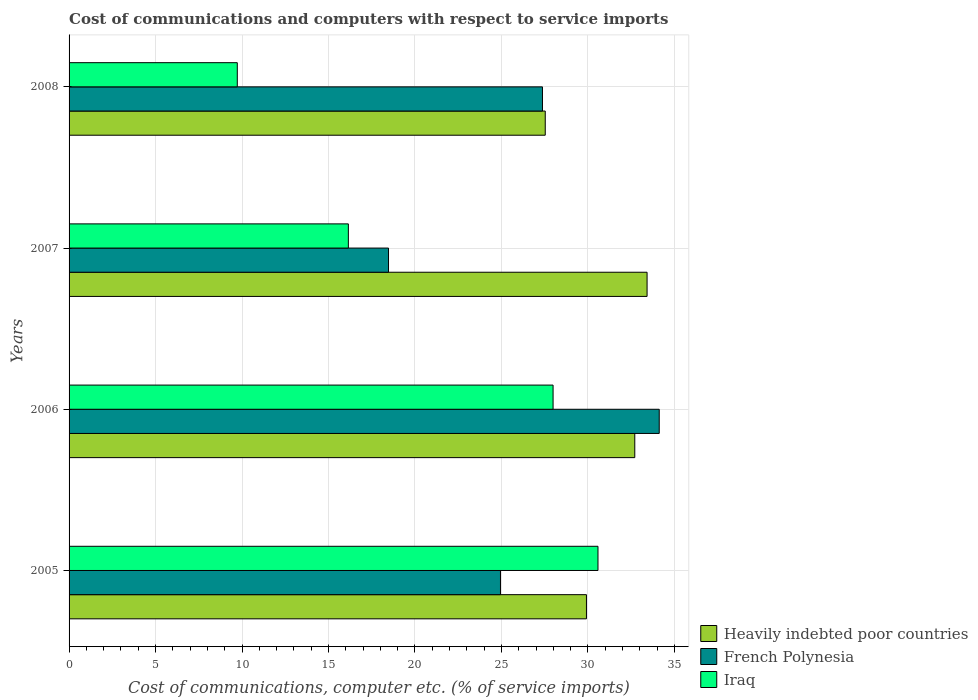How many bars are there on the 3rd tick from the top?
Your answer should be compact. 3. How many bars are there on the 4th tick from the bottom?
Offer a terse response. 3. What is the label of the 4th group of bars from the top?
Your response must be concise. 2005. In how many cases, is the number of bars for a given year not equal to the number of legend labels?
Provide a succinct answer. 0. What is the cost of communications and computers in Iraq in 2006?
Give a very brief answer. 27.99. Across all years, what is the maximum cost of communications and computers in Iraq?
Keep it short and to the point. 30.58. Across all years, what is the minimum cost of communications and computers in Iraq?
Your response must be concise. 9.73. In which year was the cost of communications and computers in Heavily indebted poor countries minimum?
Keep it short and to the point. 2008. What is the total cost of communications and computers in Heavily indebted poor countries in the graph?
Give a very brief answer. 123.58. What is the difference between the cost of communications and computers in Iraq in 2006 and that in 2008?
Keep it short and to the point. 18.26. What is the difference between the cost of communications and computers in Iraq in 2006 and the cost of communications and computers in French Polynesia in 2008?
Your answer should be very brief. 0.61. What is the average cost of communications and computers in Iraq per year?
Keep it short and to the point. 21.11. In the year 2005, what is the difference between the cost of communications and computers in Iraq and cost of communications and computers in French Polynesia?
Provide a short and direct response. 5.64. In how many years, is the cost of communications and computers in Heavily indebted poor countries greater than 17 %?
Your response must be concise. 4. What is the ratio of the cost of communications and computers in French Polynesia in 2005 to that in 2007?
Offer a very short reply. 1.35. Is the cost of communications and computers in Heavily indebted poor countries in 2005 less than that in 2007?
Keep it short and to the point. Yes. What is the difference between the highest and the second highest cost of communications and computers in Heavily indebted poor countries?
Your answer should be very brief. 0.71. What is the difference between the highest and the lowest cost of communications and computers in Iraq?
Your answer should be compact. 20.86. In how many years, is the cost of communications and computers in Iraq greater than the average cost of communications and computers in Iraq taken over all years?
Your answer should be very brief. 2. What does the 1st bar from the top in 2005 represents?
Ensure brevity in your answer.  Iraq. What does the 2nd bar from the bottom in 2007 represents?
Your answer should be compact. French Polynesia. Is it the case that in every year, the sum of the cost of communications and computers in French Polynesia and cost of communications and computers in Heavily indebted poor countries is greater than the cost of communications and computers in Iraq?
Provide a short and direct response. Yes. Are all the bars in the graph horizontal?
Offer a terse response. Yes. What is the difference between two consecutive major ticks on the X-axis?
Your answer should be very brief. 5. Does the graph contain any zero values?
Ensure brevity in your answer.  No. Does the graph contain grids?
Make the answer very short. Yes. Where does the legend appear in the graph?
Provide a short and direct response. Bottom right. What is the title of the graph?
Offer a terse response. Cost of communications and computers with respect to service imports. Does "Malaysia" appear as one of the legend labels in the graph?
Provide a short and direct response. No. What is the label or title of the X-axis?
Ensure brevity in your answer.  Cost of communications, computer etc. (% of service imports). What is the label or title of the Y-axis?
Provide a short and direct response. Years. What is the Cost of communications, computer etc. (% of service imports) of Heavily indebted poor countries in 2005?
Your response must be concise. 29.91. What is the Cost of communications, computer etc. (% of service imports) in French Polynesia in 2005?
Offer a terse response. 24.94. What is the Cost of communications, computer etc. (% of service imports) in Iraq in 2005?
Provide a short and direct response. 30.58. What is the Cost of communications, computer etc. (% of service imports) in Heavily indebted poor countries in 2006?
Your answer should be compact. 32.71. What is the Cost of communications, computer etc. (% of service imports) of French Polynesia in 2006?
Provide a short and direct response. 34.12. What is the Cost of communications, computer etc. (% of service imports) in Iraq in 2006?
Offer a terse response. 27.99. What is the Cost of communications, computer etc. (% of service imports) of Heavily indebted poor countries in 2007?
Provide a short and direct response. 33.42. What is the Cost of communications, computer etc. (% of service imports) in French Polynesia in 2007?
Make the answer very short. 18.47. What is the Cost of communications, computer etc. (% of service imports) of Iraq in 2007?
Your answer should be very brief. 16.15. What is the Cost of communications, computer etc. (% of service imports) in Heavily indebted poor countries in 2008?
Keep it short and to the point. 27.53. What is the Cost of communications, computer etc. (% of service imports) in French Polynesia in 2008?
Your response must be concise. 27.37. What is the Cost of communications, computer etc. (% of service imports) of Iraq in 2008?
Your response must be concise. 9.73. Across all years, what is the maximum Cost of communications, computer etc. (% of service imports) of Heavily indebted poor countries?
Ensure brevity in your answer.  33.42. Across all years, what is the maximum Cost of communications, computer etc. (% of service imports) in French Polynesia?
Your response must be concise. 34.12. Across all years, what is the maximum Cost of communications, computer etc. (% of service imports) of Iraq?
Make the answer very short. 30.58. Across all years, what is the minimum Cost of communications, computer etc. (% of service imports) of Heavily indebted poor countries?
Ensure brevity in your answer.  27.53. Across all years, what is the minimum Cost of communications, computer etc. (% of service imports) of French Polynesia?
Ensure brevity in your answer.  18.47. Across all years, what is the minimum Cost of communications, computer etc. (% of service imports) of Iraq?
Your answer should be very brief. 9.73. What is the total Cost of communications, computer etc. (% of service imports) in Heavily indebted poor countries in the graph?
Provide a succinct answer. 123.58. What is the total Cost of communications, computer etc. (% of service imports) in French Polynesia in the graph?
Make the answer very short. 104.91. What is the total Cost of communications, computer etc. (% of service imports) in Iraq in the graph?
Your response must be concise. 84.44. What is the difference between the Cost of communications, computer etc. (% of service imports) of Heavily indebted poor countries in 2005 and that in 2006?
Your answer should be very brief. -2.79. What is the difference between the Cost of communications, computer etc. (% of service imports) of French Polynesia in 2005 and that in 2006?
Your answer should be very brief. -9.18. What is the difference between the Cost of communications, computer etc. (% of service imports) of Iraq in 2005 and that in 2006?
Give a very brief answer. 2.6. What is the difference between the Cost of communications, computer etc. (% of service imports) of Heavily indebted poor countries in 2005 and that in 2007?
Ensure brevity in your answer.  -3.51. What is the difference between the Cost of communications, computer etc. (% of service imports) in French Polynesia in 2005 and that in 2007?
Give a very brief answer. 6.47. What is the difference between the Cost of communications, computer etc. (% of service imports) of Iraq in 2005 and that in 2007?
Give a very brief answer. 14.43. What is the difference between the Cost of communications, computer etc. (% of service imports) in Heavily indebted poor countries in 2005 and that in 2008?
Your response must be concise. 2.38. What is the difference between the Cost of communications, computer etc. (% of service imports) of French Polynesia in 2005 and that in 2008?
Offer a very short reply. -2.43. What is the difference between the Cost of communications, computer etc. (% of service imports) of Iraq in 2005 and that in 2008?
Offer a terse response. 20.86. What is the difference between the Cost of communications, computer etc. (% of service imports) in Heavily indebted poor countries in 2006 and that in 2007?
Offer a terse response. -0.71. What is the difference between the Cost of communications, computer etc. (% of service imports) of French Polynesia in 2006 and that in 2007?
Provide a succinct answer. 15.65. What is the difference between the Cost of communications, computer etc. (% of service imports) in Iraq in 2006 and that in 2007?
Provide a short and direct response. 11.84. What is the difference between the Cost of communications, computer etc. (% of service imports) of Heavily indebted poor countries in 2006 and that in 2008?
Give a very brief answer. 5.18. What is the difference between the Cost of communications, computer etc. (% of service imports) in French Polynesia in 2006 and that in 2008?
Your answer should be very brief. 6.75. What is the difference between the Cost of communications, computer etc. (% of service imports) in Iraq in 2006 and that in 2008?
Provide a short and direct response. 18.26. What is the difference between the Cost of communications, computer etc. (% of service imports) of Heavily indebted poor countries in 2007 and that in 2008?
Your answer should be very brief. 5.89. What is the difference between the Cost of communications, computer etc. (% of service imports) in French Polynesia in 2007 and that in 2008?
Provide a short and direct response. -8.9. What is the difference between the Cost of communications, computer etc. (% of service imports) of Iraq in 2007 and that in 2008?
Offer a very short reply. 6.42. What is the difference between the Cost of communications, computer etc. (% of service imports) in Heavily indebted poor countries in 2005 and the Cost of communications, computer etc. (% of service imports) in French Polynesia in 2006?
Offer a terse response. -4.21. What is the difference between the Cost of communications, computer etc. (% of service imports) in Heavily indebted poor countries in 2005 and the Cost of communications, computer etc. (% of service imports) in Iraq in 2006?
Ensure brevity in your answer.  1.93. What is the difference between the Cost of communications, computer etc. (% of service imports) in French Polynesia in 2005 and the Cost of communications, computer etc. (% of service imports) in Iraq in 2006?
Provide a short and direct response. -3.04. What is the difference between the Cost of communications, computer etc. (% of service imports) of Heavily indebted poor countries in 2005 and the Cost of communications, computer etc. (% of service imports) of French Polynesia in 2007?
Make the answer very short. 11.44. What is the difference between the Cost of communications, computer etc. (% of service imports) of Heavily indebted poor countries in 2005 and the Cost of communications, computer etc. (% of service imports) of Iraq in 2007?
Keep it short and to the point. 13.77. What is the difference between the Cost of communications, computer etc. (% of service imports) of French Polynesia in 2005 and the Cost of communications, computer etc. (% of service imports) of Iraq in 2007?
Offer a very short reply. 8.8. What is the difference between the Cost of communications, computer etc. (% of service imports) in Heavily indebted poor countries in 2005 and the Cost of communications, computer etc. (% of service imports) in French Polynesia in 2008?
Your response must be concise. 2.54. What is the difference between the Cost of communications, computer etc. (% of service imports) of Heavily indebted poor countries in 2005 and the Cost of communications, computer etc. (% of service imports) of Iraq in 2008?
Give a very brief answer. 20.19. What is the difference between the Cost of communications, computer etc. (% of service imports) in French Polynesia in 2005 and the Cost of communications, computer etc. (% of service imports) in Iraq in 2008?
Your answer should be compact. 15.22. What is the difference between the Cost of communications, computer etc. (% of service imports) of Heavily indebted poor countries in 2006 and the Cost of communications, computer etc. (% of service imports) of French Polynesia in 2007?
Give a very brief answer. 14.24. What is the difference between the Cost of communications, computer etc. (% of service imports) of Heavily indebted poor countries in 2006 and the Cost of communications, computer etc. (% of service imports) of Iraq in 2007?
Your response must be concise. 16.56. What is the difference between the Cost of communications, computer etc. (% of service imports) in French Polynesia in 2006 and the Cost of communications, computer etc. (% of service imports) in Iraq in 2007?
Offer a terse response. 17.98. What is the difference between the Cost of communications, computer etc. (% of service imports) in Heavily indebted poor countries in 2006 and the Cost of communications, computer etc. (% of service imports) in French Polynesia in 2008?
Your answer should be compact. 5.34. What is the difference between the Cost of communications, computer etc. (% of service imports) in Heavily indebted poor countries in 2006 and the Cost of communications, computer etc. (% of service imports) in Iraq in 2008?
Keep it short and to the point. 22.98. What is the difference between the Cost of communications, computer etc. (% of service imports) of French Polynesia in 2006 and the Cost of communications, computer etc. (% of service imports) of Iraq in 2008?
Provide a succinct answer. 24.4. What is the difference between the Cost of communications, computer etc. (% of service imports) in Heavily indebted poor countries in 2007 and the Cost of communications, computer etc. (% of service imports) in French Polynesia in 2008?
Ensure brevity in your answer.  6.05. What is the difference between the Cost of communications, computer etc. (% of service imports) of Heavily indebted poor countries in 2007 and the Cost of communications, computer etc. (% of service imports) of Iraq in 2008?
Offer a very short reply. 23.69. What is the difference between the Cost of communications, computer etc. (% of service imports) in French Polynesia in 2007 and the Cost of communications, computer etc. (% of service imports) in Iraq in 2008?
Ensure brevity in your answer.  8.74. What is the average Cost of communications, computer etc. (% of service imports) of Heavily indebted poor countries per year?
Offer a terse response. 30.89. What is the average Cost of communications, computer etc. (% of service imports) in French Polynesia per year?
Provide a succinct answer. 26.23. What is the average Cost of communications, computer etc. (% of service imports) in Iraq per year?
Ensure brevity in your answer.  21.11. In the year 2005, what is the difference between the Cost of communications, computer etc. (% of service imports) of Heavily indebted poor countries and Cost of communications, computer etc. (% of service imports) of French Polynesia?
Make the answer very short. 4.97. In the year 2005, what is the difference between the Cost of communications, computer etc. (% of service imports) in Heavily indebted poor countries and Cost of communications, computer etc. (% of service imports) in Iraq?
Give a very brief answer. -0.67. In the year 2005, what is the difference between the Cost of communications, computer etc. (% of service imports) of French Polynesia and Cost of communications, computer etc. (% of service imports) of Iraq?
Ensure brevity in your answer.  -5.64. In the year 2006, what is the difference between the Cost of communications, computer etc. (% of service imports) of Heavily indebted poor countries and Cost of communications, computer etc. (% of service imports) of French Polynesia?
Offer a terse response. -1.41. In the year 2006, what is the difference between the Cost of communications, computer etc. (% of service imports) in Heavily indebted poor countries and Cost of communications, computer etc. (% of service imports) in Iraq?
Offer a terse response. 4.72. In the year 2006, what is the difference between the Cost of communications, computer etc. (% of service imports) of French Polynesia and Cost of communications, computer etc. (% of service imports) of Iraq?
Keep it short and to the point. 6.14. In the year 2007, what is the difference between the Cost of communications, computer etc. (% of service imports) in Heavily indebted poor countries and Cost of communications, computer etc. (% of service imports) in French Polynesia?
Provide a succinct answer. 14.95. In the year 2007, what is the difference between the Cost of communications, computer etc. (% of service imports) in Heavily indebted poor countries and Cost of communications, computer etc. (% of service imports) in Iraq?
Offer a very short reply. 17.27. In the year 2007, what is the difference between the Cost of communications, computer etc. (% of service imports) of French Polynesia and Cost of communications, computer etc. (% of service imports) of Iraq?
Provide a short and direct response. 2.32. In the year 2008, what is the difference between the Cost of communications, computer etc. (% of service imports) of Heavily indebted poor countries and Cost of communications, computer etc. (% of service imports) of French Polynesia?
Your answer should be very brief. 0.16. In the year 2008, what is the difference between the Cost of communications, computer etc. (% of service imports) of Heavily indebted poor countries and Cost of communications, computer etc. (% of service imports) of Iraq?
Provide a succinct answer. 17.81. In the year 2008, what is the difference between the Cost of communications, computer etc. (% of service imports) of French Polynesia and Cost of communications, computer etc. (% of service imports) of Iraq?
Your answer should be very brief. 17.65. What is the ratio of the Cost of communications, computer etc. (% of service imports) of Heavily indebted poor countries in 2005 to that in 2006?
Give a very brief answer. 0.91. What is the ratio of the Cost of communications, computer etc. (% of service imports) in French Polynesia in 2005 to that in 2006?
Offer a very short reply. 0.73. What is the ratio of the Cost of communications, computer etc. (% of service imports) of Iraq in 2005 to that in 2006?
Provide a short and direct response. 1.09. What is the ratio of the Cost of communications, computer etc. (% of service imports) in Heavily indebted poor countries in 2005 to that in 2007?
Your answer should be compact. 0.9. What is the ratio of the Cost of communications, computer etc. (% of service imports) of French Polynesia in 2005 to that in 2007?
Offer a terse response. 1.35. What is the ratio of the Cost of communications, computer etc. (% of service imports) in Iraq in 2005 to that in 2007?
Offer a terse response. 1.89. What is the ratio of the Cost of communications, computer etc. (% of service imports) in Heavily indebted poor countries in 2005 to that in 2008?
Your answer should be compact. 1.09. What is the ratio of the Cost of communications, computer etc. (% of service imports) in French Polynesia in 2005 to that in 2008?
Give a very brief answer. 0.91. What is the ratio of the Cost of communications, computer etc. (% of service imports) of Iraq in 2005 to that in 2008?
Your response must be concise. 3.14. What is the ratio of the Cost of communications, computer etc. (% of service imports) of Heavily indebted poor countries in 2006 to that in 2007?
Offer a very short reply. 0.98. What is the ratio of the Cost of communications, computer etc. (% of service imports) in French Polynesia in 2006 to that in 2007?
Provide a short and direct response. 1.85. What is the ratio of the Cost of communications, computer etc. (% of service imports) of Iraq in 2006 to that in 2007?
Ensure brevity in your answer.  1.73. What is the ratio of the Cost of communications, computer etc. (% of service imports) of Heavily indebted poor countries in 2006 to that in 2008?
Give a very brief answer. 1.19. What is the ratio of the Cost of communications, computer etc. (% of service imports) in French Polynesia in 2006 to that in 2008?
Ensure brevity in your answer.  1.25. What is the ratio of the Cost of communications, computer etc. (% of service imports) in Iraq in 2006 to that in 2008?
Ensure brevity in your answer.  2.88. What is the ratio of the Cost of communications, computer etc. (% of service imports) in Heavily indebted poor countries in 2007 to that in 2008?
Offer a terse response. 1.21. What is the ratio of the Cost of communications, computer etc. (% of service imports) of French Polynesia in 2007 to that in 2008?
Give a very brief answer. 0.67. What is the ratio of the Cost of communications, computer etc. (% of service imports) in Iraq in 2007 to that in 2008?
Give a very brief answer. 1.66. What is the difference between the highest and the second highest Cost of communications, computer etc. (% of service imports) of Heavily indebted poor countries?
Make the answer very short. 0.71. What is the difference between the highest and the second highest Cost of communications, computer etc. (% of service imports) of French Polynesia?
Provide a short and direct response. 6.75. What is the difference between the highest and the second highest Cost of communications, computer etc. (% of service imports) of Iraq?
Your response must be concise. 2.6. What is the difference between the highest and the lowest Cost of communications, computer etc. (% of service imports) in Heavily indebted poor countries?
Your answer should be compact. 5.89. What is the difference between the highest and the lowest Cost of communications, computer etc. (% of service imports) of French Polynesia?
Give a very brief answer. 15.65. What is the difference between the highest and the lowest Cost of communications, computer etc. (% of service imports) in Iraq?
Offer a very short reply. 20.86. 